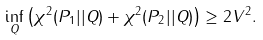Convert formula to latex. <formula><loc_0><loc_0><loc_500><loc_500>\inf _ { Q } \left ( \chi ^ { 2 } ( P _ { 1 } | | Q ) + \chi ^ { 2 } ( P _ { 2 } | | Q ) \right ) \geq 2 V ^ { 2 } .</formula> 